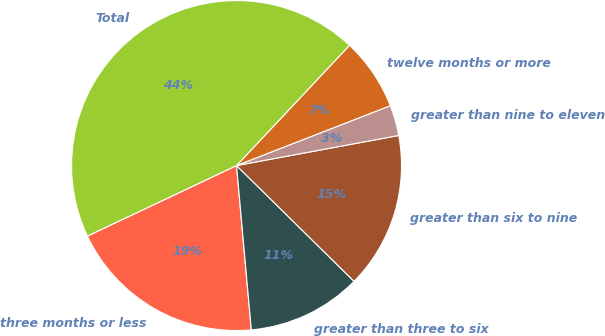Convert chart to OTSL. <chart><loc_0><loc_0><loc_500><loc_500><pie_chart><fcel>three months or less<fcel>greater than three to six<fcel>greater than six to nine<fcel>greater than nine to eleven<fcel>twelve months or more<fcel>Total<nl><fcel>19.4%<fcel>11.19%<fcel>15.3%<fcel>2.99%<fcel>7.09%<fcel>44.03%<nl></chart> 